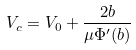Convert formula to latex. <formula><loc_0><loc_0><loc_500><loc_500>V _ { c } = V _ { 0 } + \frac { 2 b } { \mu \Phi ^ { \prime } ( b ) }</formula> 